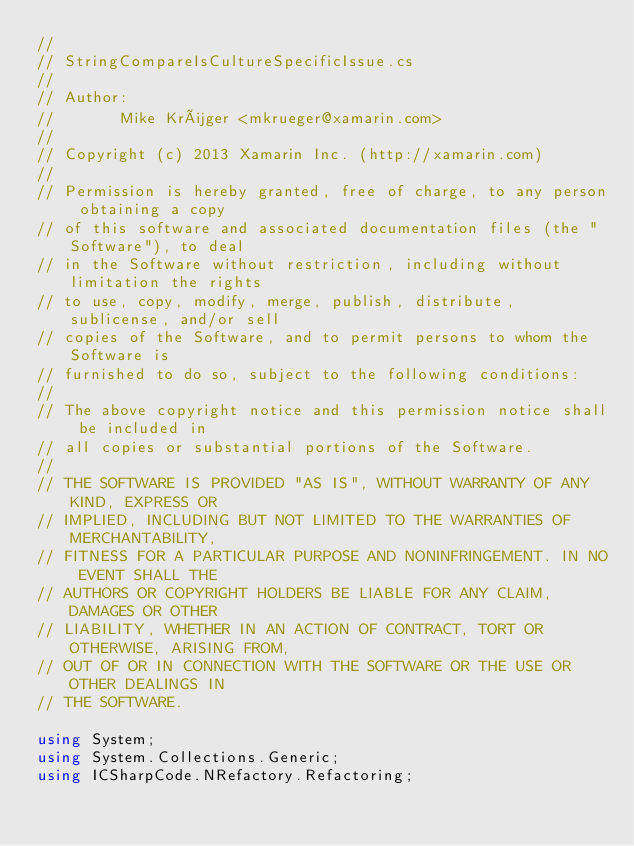<code> <loc_0><loc_0><loc_500><loc_500><_C#_>//
// StringCompareIsCultureSpecificIssue.cs
//
// Author:
//       Mike Krüger <mkrueger@xamarin.com>
//
// Copyright (c) 2013 Xamarin Inc. (http://xamarin.com)
//
// Permission is hereby granted, free of charge, to any person obtaining a copy
// of this software and associated documentation files (the "Software"), to deal
// in the Software without restriction, including without limitation the rights
// to use, copy, modify, merge, publish, distribute, sublicense, and/or sell
// copies of the Software, and to permit persons to whom the Software is
// furnished to do so, subject to the following conditions:
//
// The above copyright notice and this permission notice shall be included in
// all copies or substantial portions of the Software.
//
// THE SOFTWARE IS PROVIDED "AS IS", WITHOUT WARRANTY OF ANY KIND, EXPRESS OR
// IMPLIED, INCLUDING BUT NOT LIMITED TO THE WARRANTIES OF MERCHANTABILITY,
// FITNESS FOR A PARTICULAR PURPOSE AND NONINFRINGEMENT. IN NO EVENT SHALL THE
// AUTHORS OR COPYRIGHT HOLDERS BE LIABLE FOR ANY CLAIM, DAMAGES OR OTHER
// LIABILITY, WHETHER IN AN ACTION OF CONTRACT, TORT OR OTHERWISE, ARISING FROM,
// OUT OF OR IN CONNECTION WITH THE SOFTWARE OR THE USE OR OTHER DEALINGS IN
// THE SOFTWARE.

using System;
using System.Collections.Generic;
using ICSharpCode.NRefactory.Refactoring;</code> 